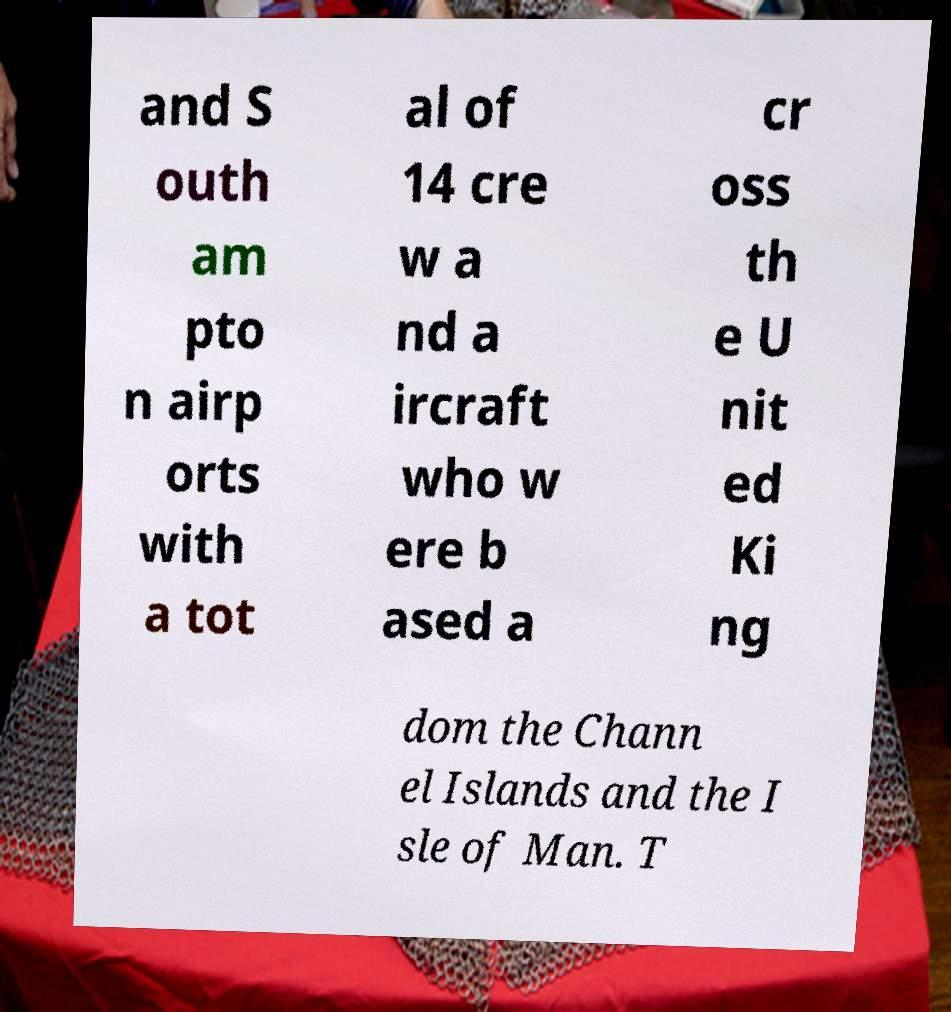Please read and relay the text visible in this image. What does it say? and S outh am pto n airp orts with a tot al of 14 cre w a nd a ircraft who w ere b ased a cr oss th e U nit ed Ki ng dom the Chann el Islands and the I sle of Man. T 